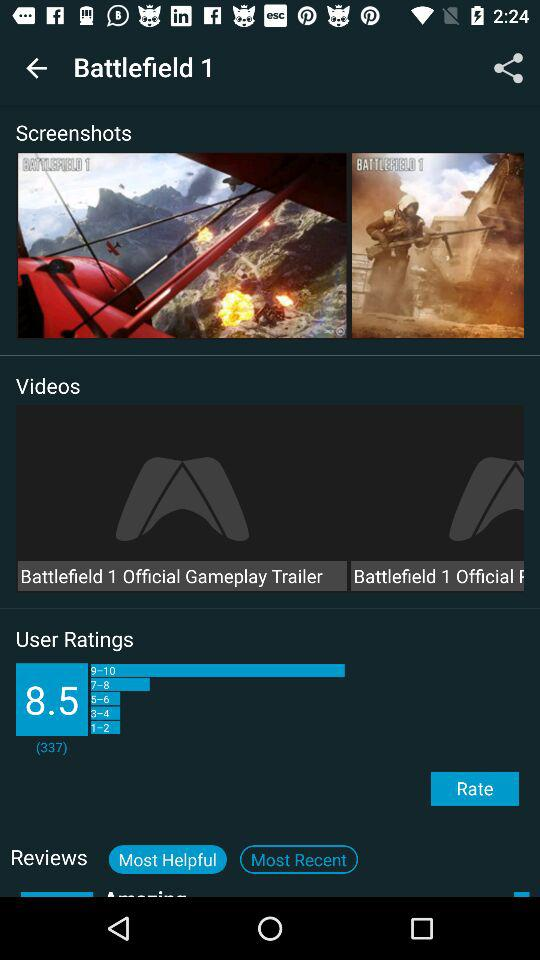What's the average rating given by the users? The average rating is 8.5. 